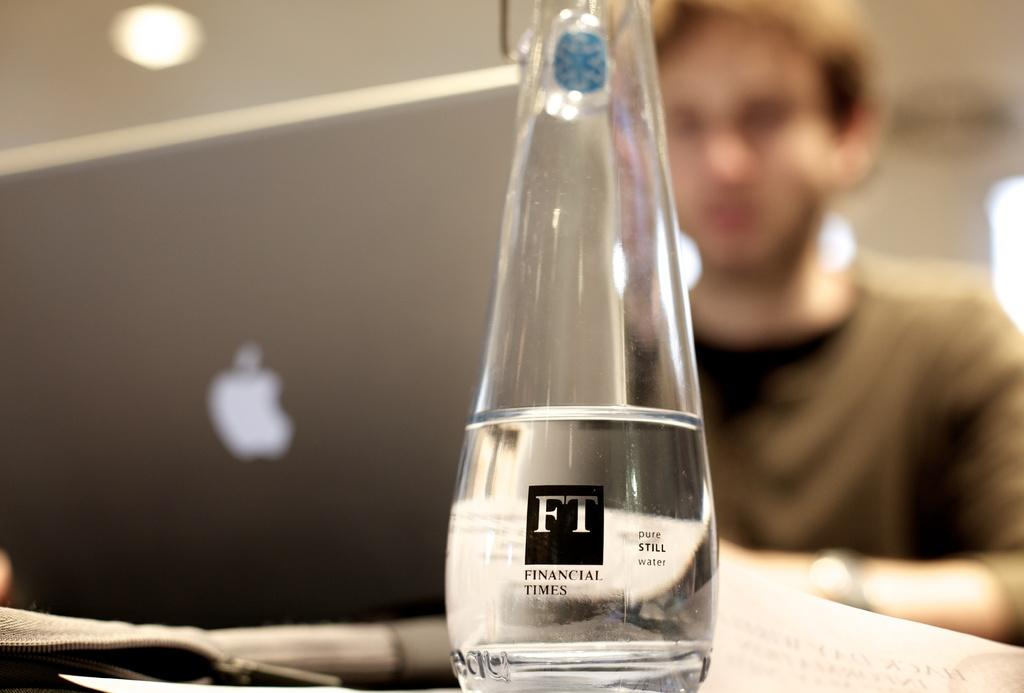<image>
Share a concise interpretation of the image provided. A clear bottle from Financial Times with a Macbook in the background with somone sitting at it. 